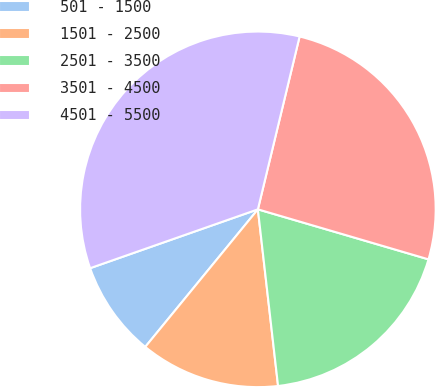Convert chart to OTSL. <chart><loc_0><loc_0><loc_500><loc_500><pie_chart><fcel>501 - 1500<fcel>1501 - 2500<fcel>2501 - 3500<fcel>3501 - 4500<fcel>4501 - 5500<nl><fcel>8.71%<fcel>12.73%<fcel>18.65%<fcel>25.77%<fcel>34.14%<nl></chart> 